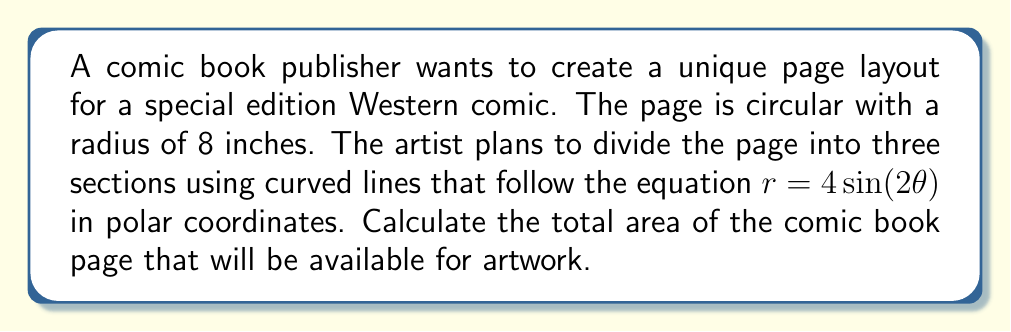Can you solve this math problem? To solve this problem, we need to follow these steps:

1) First, we need to calculate the area of the entire circular page:
   $$A_{circle} = \pi r^2 = \pi (8^2) = 64\pi \text{ square inches}$$

2) Next, we need to calculate the area enclosed by the curve $r = 4\sin(2\theta)$. In polar coordinates, the area formula is:
   $$A = \frac{1}{2}\int_0^{2\pi} r^2 d\theta$$

3) Substituting our equation:
   $$A = \frac{1}{2}\int_0^{2\pi} (4\sin(2\theta))^2 d\theta$$

4) Simplify:
   $$A = 8\int_0^{2\pi} \sin^2(2\theta) d\theta$$

5) Using the trigonometric identity $\sin^2(x) = \frac{1 - \cos(2x)}{2}$:
   $$A = 8\int_0^{2\pi} \frac{1 - \cos(4\theta)}{2} d\theta$$

6) Simplify:
   $$A = 4\int_0^{2\pi} (1 - \cos(4\theta)) d\theta$$

7) Integrate:
   $$A = 4[\theta - \frac{1}{4}\sin(4\theta)]_0^{2\pi}$$

8) Evaluate:
   $$A = 4[2\pi - 0 - (0 - 0)] = 8\pi \text{ square inches}$$

9) The area available for artwork is the difference between the total page area and the area enclosed by the curve:
   $$A_{artwork} = A_{circle} - A_{curve} = 64\pi - 8\pi = 56\pi \text{ square inches}$$

[asy]
import graph;
size(200);
real f(real t) {return 4*sin(2*t);}
draw(polargraph(f,0,2*pi,operator ..),blue);
draw(scale(8)*unitcircle, red);
label("$r = 4\sin(2\theta)$", (3,3), blue);
label("Page boundary", (6,-6), red);
[/asy]
Answer: The total area available for artwork on the comic book page is $56\pi$ square inches, or approximately 175.92 square inches. 